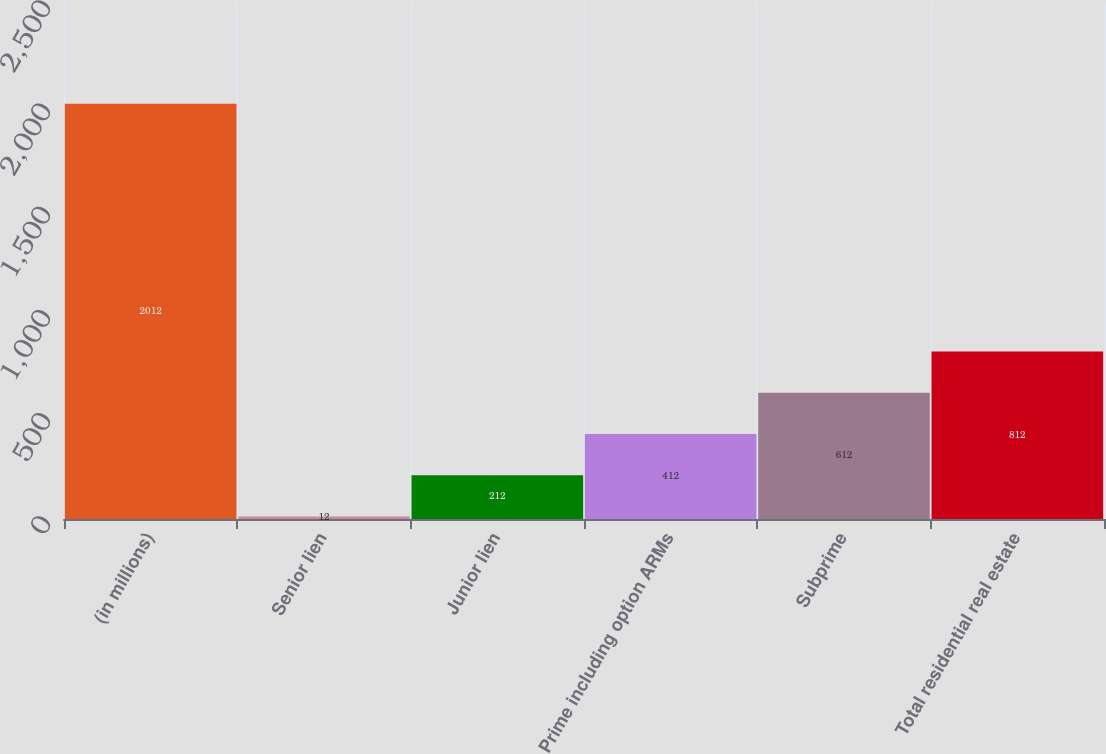<chart> <loc_0><loc_0><loc_500><loc_500><bar_chart><fcel>(in millions)<fcel>Senior lien<fcel>Junior lien<fcel>Prime including option ARMs<fcel>Subprime<fcel>Total residential real estate<nl><fcel>2012<fcel>12<fcel>212<fcel>412<fcel>612<fcel>812<nl></chart> 